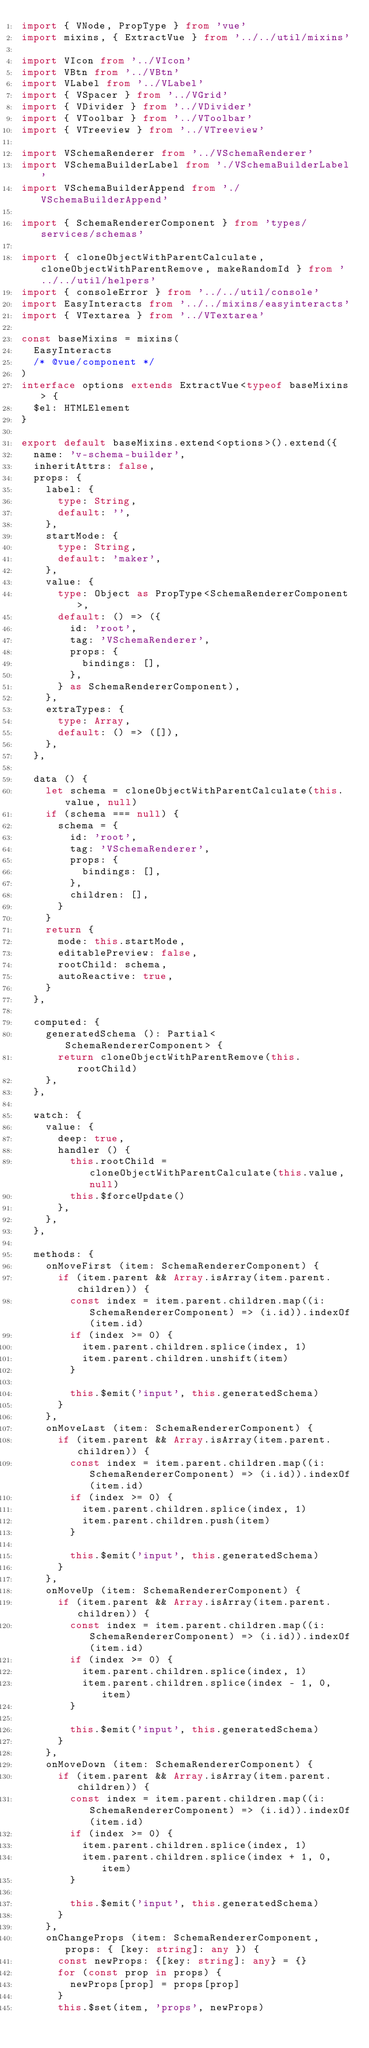<code> <loc_0><loc_0><loc_500><loc_500><_TypeScript_>import { VNode, PropType } from 'vue'
import mixins, { ExtractVue } from '../../util/mixins'

import VIcon from '../VIcon'
import VBtn from '../VBtn'
import VLabel from '../VLabel'
import { VSpacer } from '../VGrid'
import { VDivider } from '../VDivider'
import { VToolbar } from '../VToolbar'
import { VTreeview } from '../VTreeview'

import VSchemaRenderer from '../VSchemaRenderer'
import VSchemaBuilderLabel from './VSchemaBuilderLabel'
import VSchemaBuilderAppend from './VSchemaBuilderAppend'

import { SchemaRendererComponent } from 'types/services/schemas'

import { cloneObjectWithParentCalculate, cloneObjectWithParentRemove, makeRandomId } from '../../util/helpers'
import { consoleError } from '../../util/console'
import EasyInteracts from '../../mixins/easyinteracts'
import { VTextarea } from '../VTextarea'

const baseMixins = mixins(
  EasyInteracts
  /* @vue/component */
)
interface options extends ExtractVue<typeof baseMixins> {
  $el: HTMLElement
}

export default baseMixins.extend<options>().extend({
  name: 'v-schema-builder',
  inheritAttrs: false,
  props: {
    label: {
      type: String,
      default: '',
    },
    startMode: {
      type: String,
      default: 'maker',
    },
    value: {
      type: Object as PropType<SchemaRendererComponent>,
      default: () => ({
        id: 'root',
        tag: 'VSchemaRenderer',
        props: {
          bindings: [],
        },
      } as SchemaRendererComponent),
    },
    extraTypes: {
      type: Array,
      default: () => ([]),
    },
  },

  data () {
    let schema = cloneObjectWithParentCalculate(this.value, null)
    if (schema === null) {
      schema = {
        id: 'root',
        tag: 'VSchemaRenderer',
        props: {
          bindings: [],
        },
        children: [],
      }
    }
    return {
      mode: this.startMode,
      editablePreview: false,
      rootChild: schema,
      autoReactive: true,
    }
  },

  computed: {
    generatedSchema (): Partial<SchemaRendererComponent> {
      return cloneObjectWithParentRemove(this.rootChild)
    },
  },

  watch: {
    value: {
      deep: true,
      handler () {
        this.rootChild = cloneObjectWithParentCalculate(this.value, null)
        this.$forceUpdate()
      },
    },
  },

  methods: {
    onMoveFirst (item: SchemaRendererComponent) {
      if (item.parent && Array.isArray(item.parent.children)) {
        const index = item.parent.children.map((i: SchemaRendererComponent) => (i.id)).indexOf(item.id)
        if (index >= 0) {
          item.parent.children.splice(index, 1)
          item.parent.children.unshift(item)
        }

        this.$emit('input', this.generatedSchema)
      }
    },
    onMoveLast (item: SchemaRendererComponent) {
      if (item.parent && Array.isArray(item.parent.children)) {
        const index = item.parent.children.map((i: SchemaRendererComponent) => (i.id)).indexOf(item.id)
        if (index >= 0) {
          item.parent.children.splice(index, 1)
          item.parent.children.push(item)
        }

        this.$emit('input', this.generatedSchema)
      }
    },
    onMoveUp (item: SchemaRendererComponent) {
      if (item.parent && Array.isArray(item.parent.children)) {
        const index = item.parent.children.map((i: SchemaRendererComponent) => (i.id)).indexOf(item.id)
        if (index >= 0) {
          item.parent.children.splice(index, 1)
          item.parent.children.splice(index - 1, 0, item)
        }

        this.$emit('input', this.generatedSchema)
      }
    },
    onMoveDown (item: SchemaRendererComponent) {
      if (item.parent && Array.isArray(item.parent.children)) {
        const index = item.parent.children.map((i: SchemaRendererComponent) => (i.id)).indexOf(item.id)
        if (index >= 0) {
          item.parent.children.splice(index, 1)
          item.parent.children.splice(index + 1, 0, item)
        }

        this.$emit('input', this.generatedSchema)
      }
    },
    onChangeProps (item: SchemaRendererComponent, props: { [key: string]: any }) {
      const newProps: {[key: string]: any} = {}
      for (const prop in props) {
        newProps[prop] = props[prop]
      }
      this.$set(item, 'props', newProps)</code> 